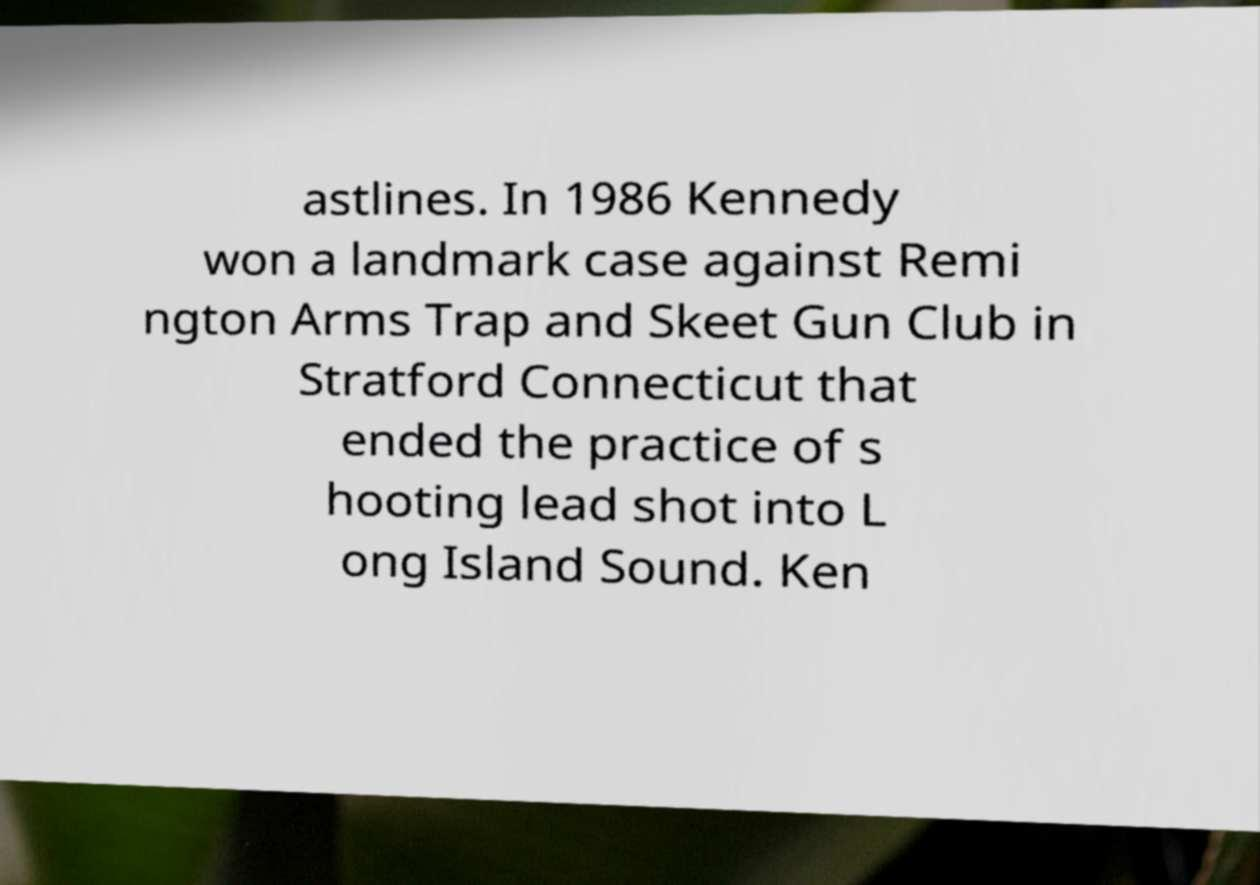Can you read and provide the text displayed in the image?This photo seems to have some interesting text. Can you extract and type it out for me? astlines. In 1986 Kennedy won a landmark case against Remi ngton Arms Trap and Skeet Gun Club in Stratford Connecticut that ended the practice of s hooting lead shot into L ong Island Sound. Ken 